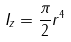<formula> <loc_0><loc_0><loc_500><loc_500>I _ { z } = \frac { \pi } { 2 } r ^ { 4 }</formula> 